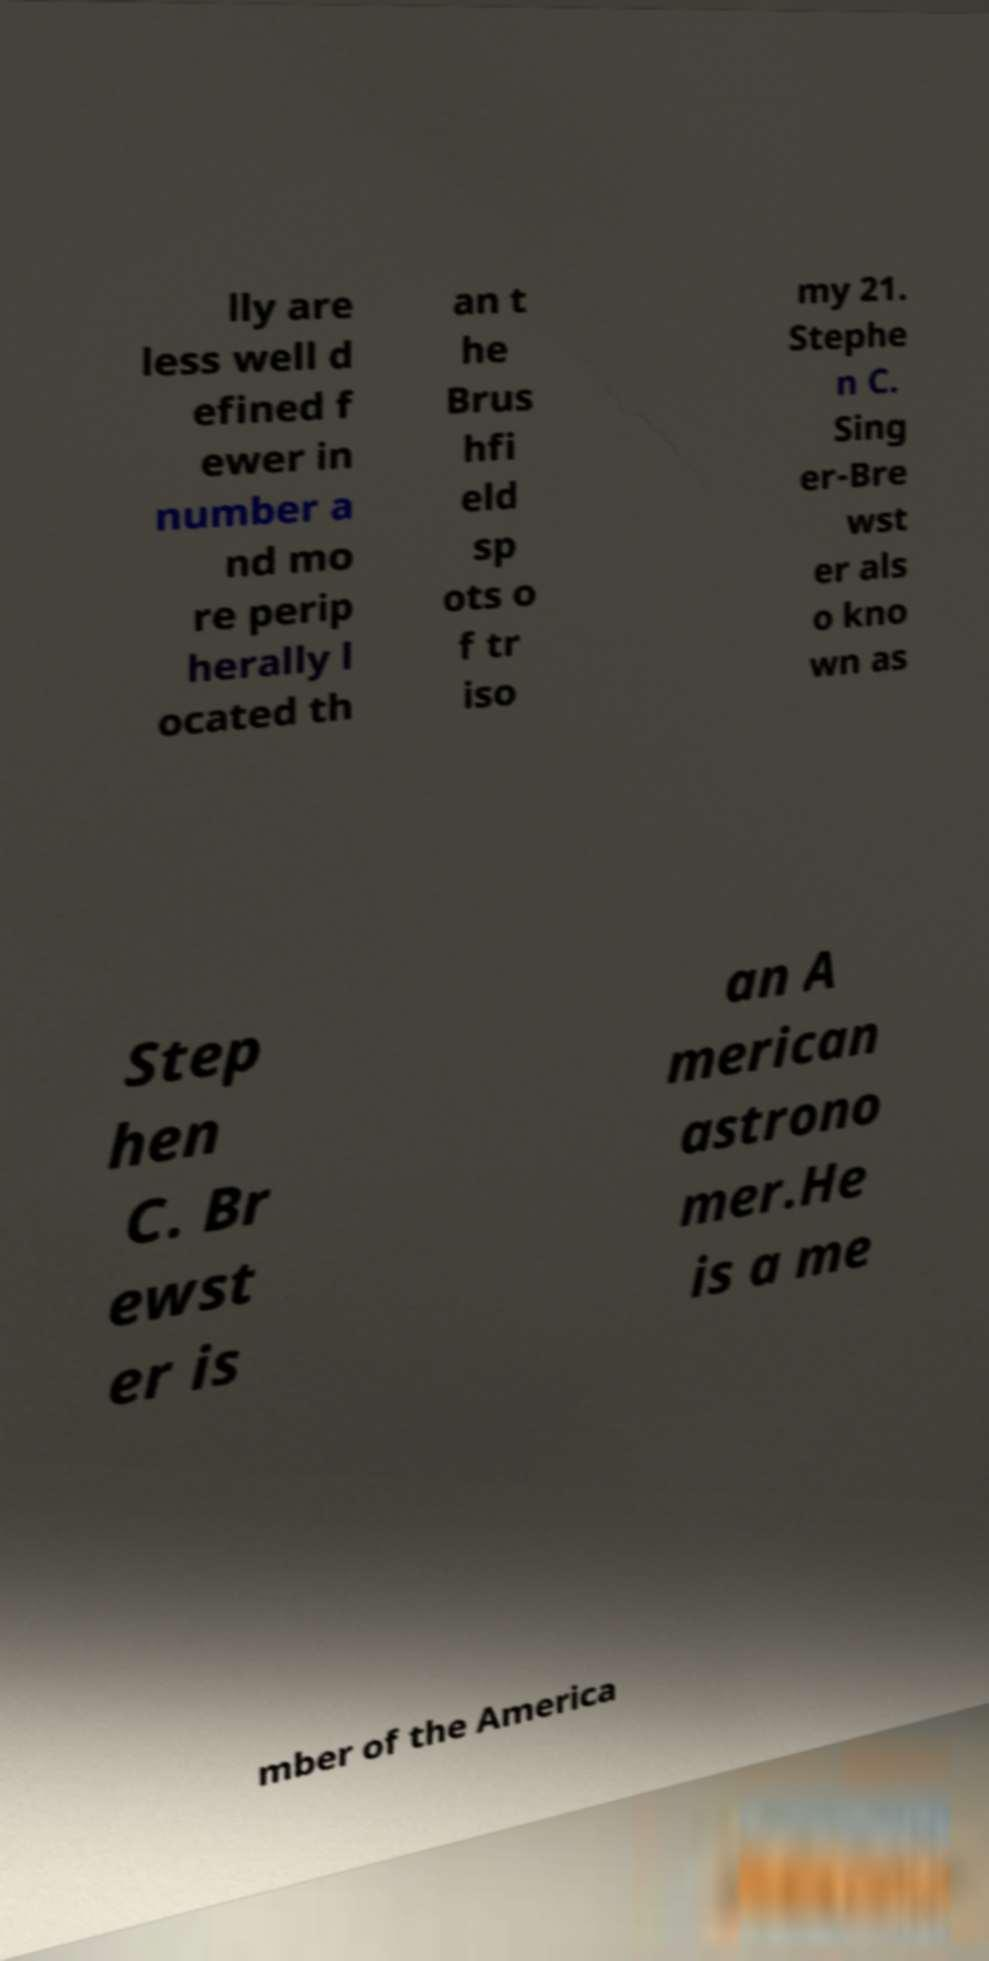Can you read and provide the text displayed in the image?This photo seems to have some interesting text. Can you extract and type it out for me? lly are less well d efined f ewer in number a nd mo re perip herally l ocated th an t he Brus hfi eld sp ots o f tr iso my 21. Stephe n C. Sing er-Bre wst er als o kno wn as Step hen C. Br ewst er is an A merican astrono mer.He is a me mber of the America 